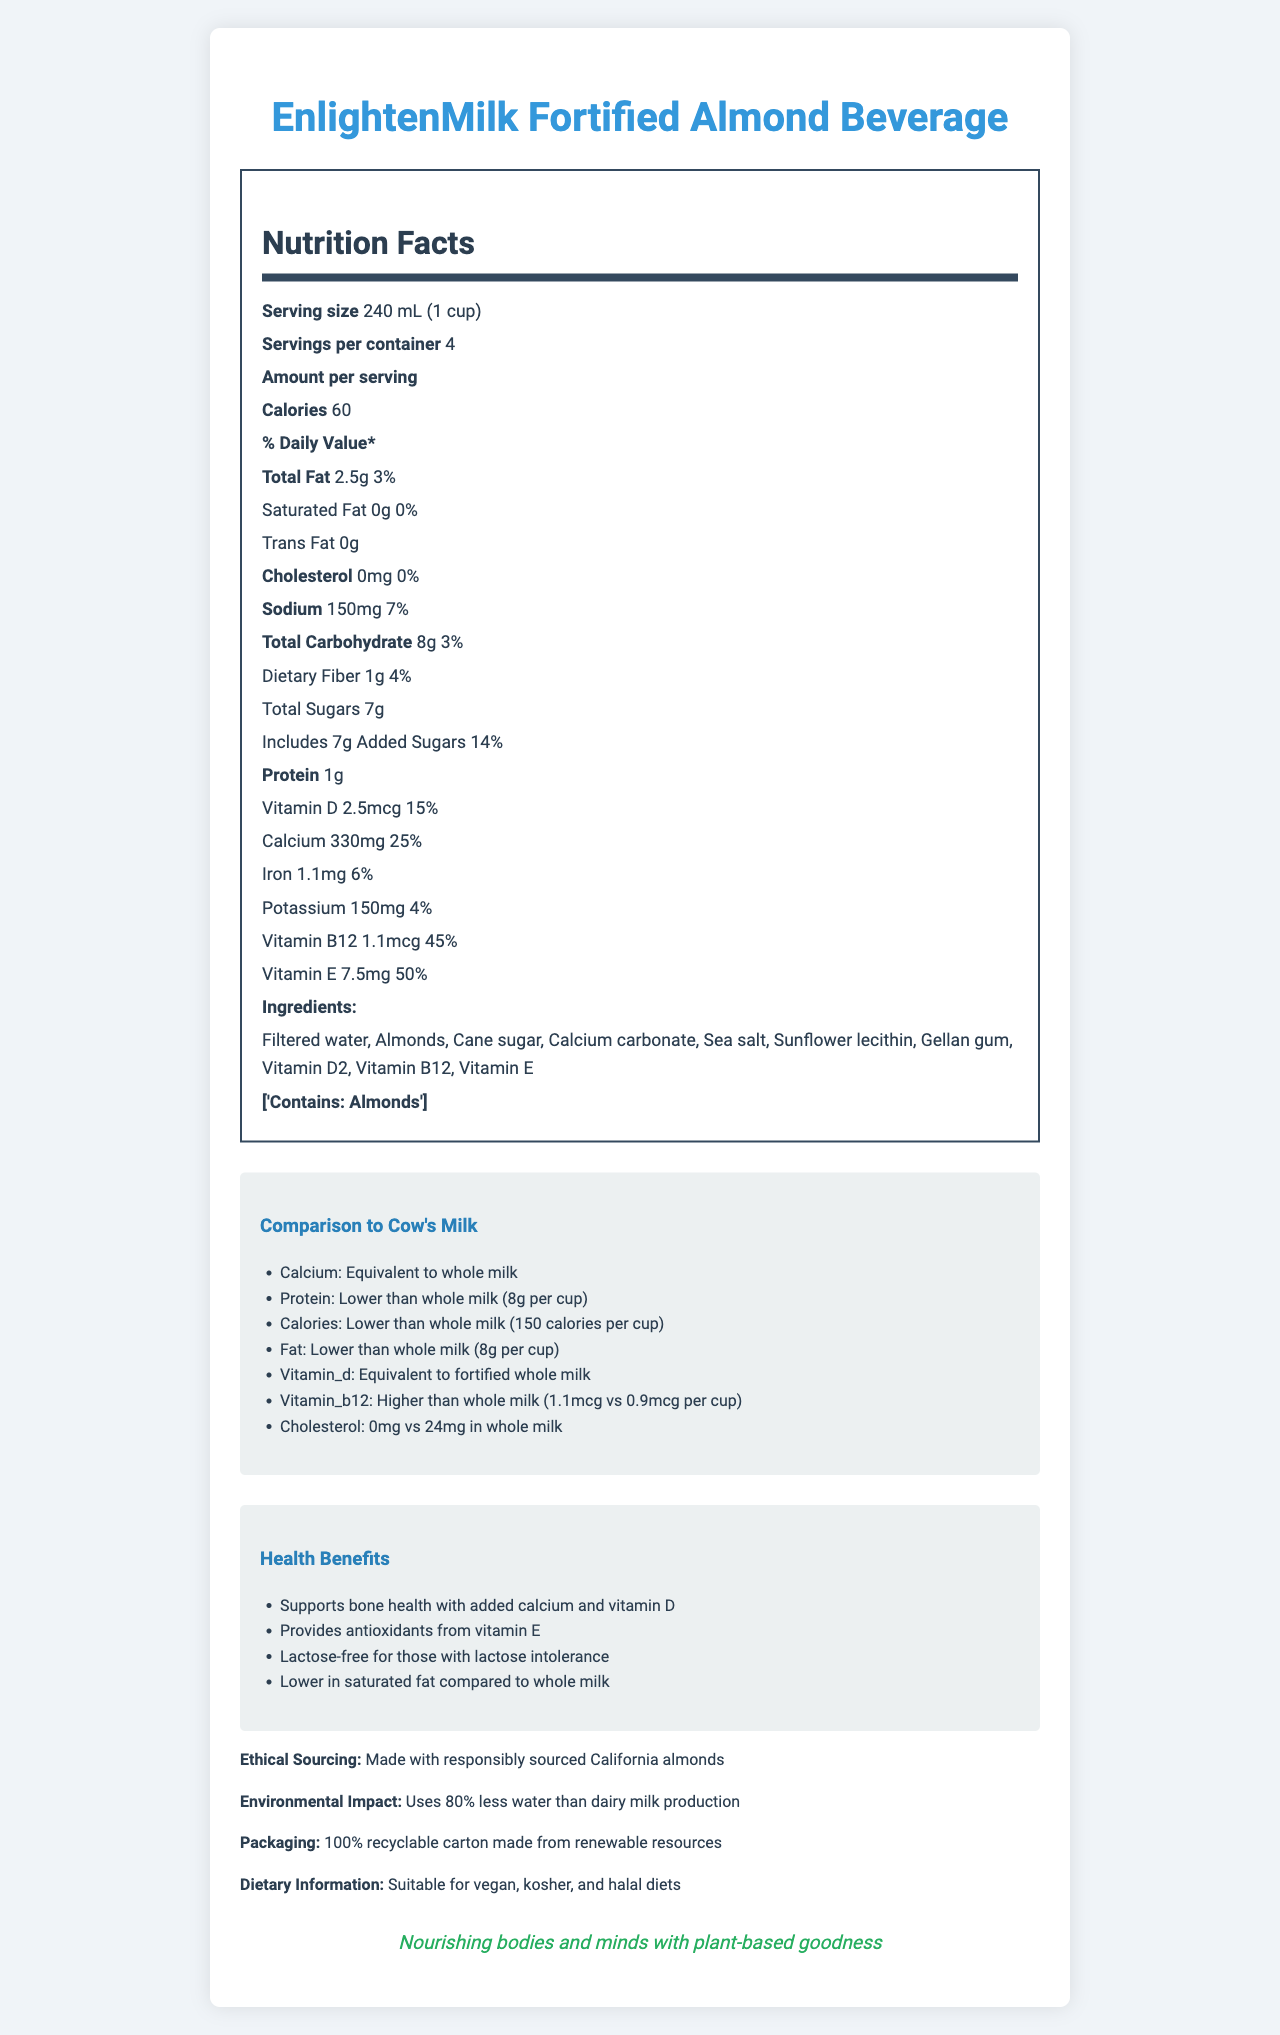what is the serving size of EnlightenMilk Fortified Almond Beverage? The document states that the serving size is 240 mL, which is equivalent to 1 cup.
Answer: 240 mL (1 cup) how many calories are in one serving? The document lists that each serving has 60 calories.
Answer: 60 what is the daily value percentage of calcium in EnlightenMilk Fortified Almond Beverage? The document indicates that the calcium daily value percentage is 25%.
Answer: 25% name two vitamins present in EnlightenMilk Fortified Almond Beverage and their daily value percentages. The document lists Vitamin D with a 15% daily value and Vitamin B12 with a 45% daily value.
Answer: Vitamin D - 15%, Vitamin B12 - 45% is there any cholesterol in EnlightenMilk Fortified Almond Beverage? The document shows that the cholesterol content is 0mg, which means there is no cholesterol.
Answer: No which milk alternative offers higher Vitamin B12 content? A. EnlightenMilk Fortified Almond Beverage B. Whole milk C. Soy milk D. Skim milk The document states that EnlightenMilk Fortified Almond Beverage has 1.1mcg of Vitamin B12, which is higher than the 0.9mcg found in whole milk.
Answer: A how does the calorie content of EnlightenMilk compare to whole milk? A. Higher B. Lower C. Same D. Double The document indicates that EnlightenMilk has 60 calories per cup, while whole milk has 150 calories per cup, thus EnlightenMilk has lower calories.
Answer: B does EnlightenMilk contain any added sugars? The document shows EnlightenMilk contains 7g of added sugars.
Answer: Yes is EnlightenMilk suitable for vegan diets? The document states that EnlightenMilk is suitable for vegan diets.
Answer: Yes Compare the environmental impact of EnlightenMilk to dairy milk. The document explicitly mentions that the production of EnlightenMilk uses 80% less water compared to dairy milk production.
Answer: EnlightenMilk uses 80% less water than dairy milk production. what are the key health benefits of EnlightenMilk Fortified Almond Beverage? The document lists that it supports bone health with added calcium and vitamin D, provides antioxidants from vitamin E, is lactose-free for those with lactose intolerance, and is lower in saturated fat compared to whole milk.
Answer: Supports bone health, provides antioxidants, lactose-free, lower in saturated fat. what is the main idea of this document? The document encompasses the nutritional profile, comparisons to cow's milk, ethical and environmental insights, and suitability for different diets, summarized in an organized manner.
Answer: The document provides detailed nutritional information about EnlightenMilk Fortified Almond Beverage, compares it to cow's milk, and highlights its health benefits, ethical sourcing, environmental impact, and suitability for various dietary needs. what is the origin of the almonds used in EnlightenMilk? The document states that the almonds are responsibly sourced from California, but does not specify the farm or additional details.
Answer: Not enough information 